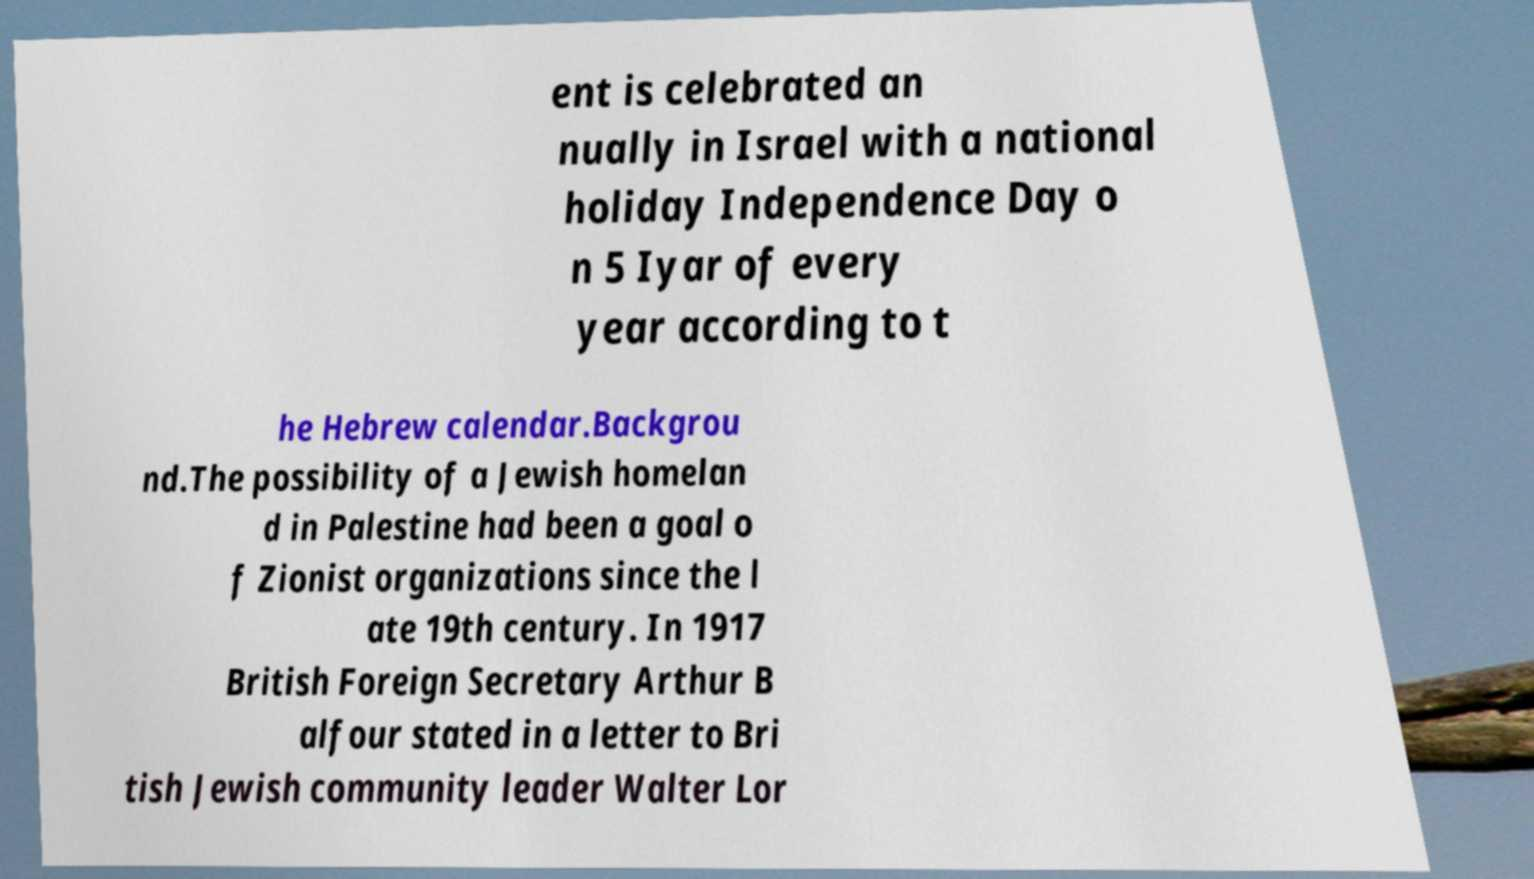What messages or text are displayed in this image? I need them in a readable, typed format. ent is celebrated an nually in Israel with a national holiday Independence Day o n 5 Iyar of every year according to t he Hebrew calendar.Backgrou nd.The possibility of a Jewish homelan d in Palestine had been a goal o f Zionist organizations since the l ate 19th century. In 1917 British Foreign Secretary Arthur B alfour stated in a letter to Bri tish Jewish community leader Walter Lor 